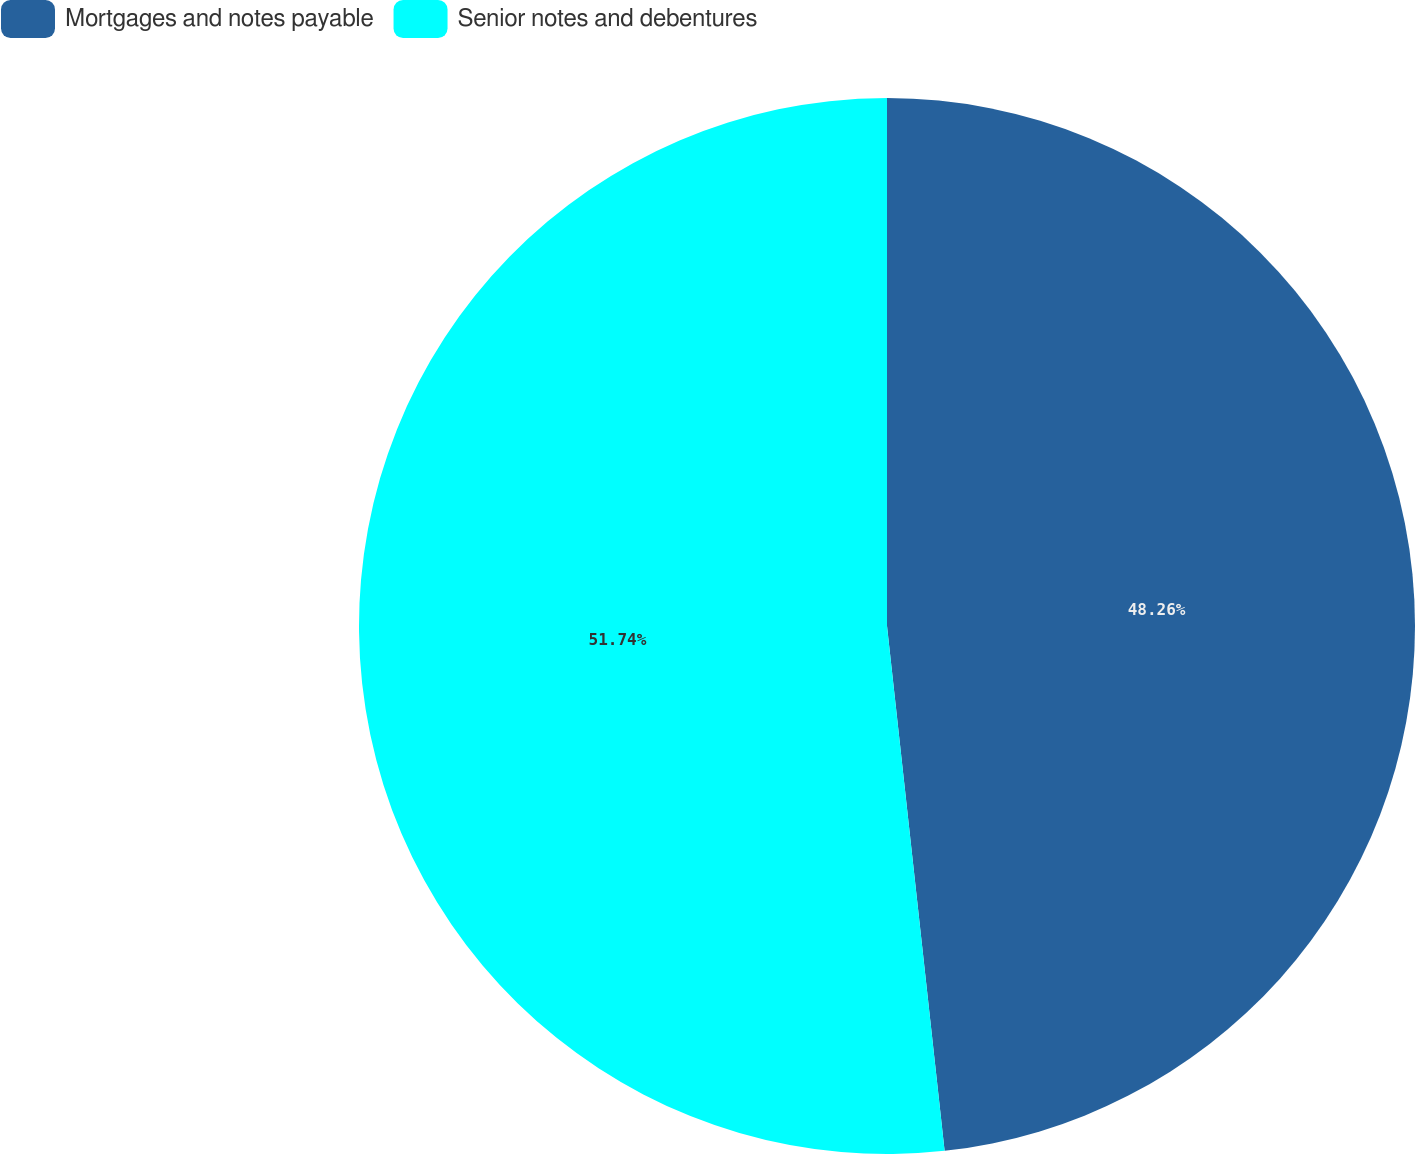Convert chart to OTSL. <chart><loc_0><loc_0><loc_500><loc_500><pie_chart><fcel>Mortgages and notes payable<fcel>Senior notes and debentures<nl><fcel>48.26%<fcel>51.74%<nl></chart> 